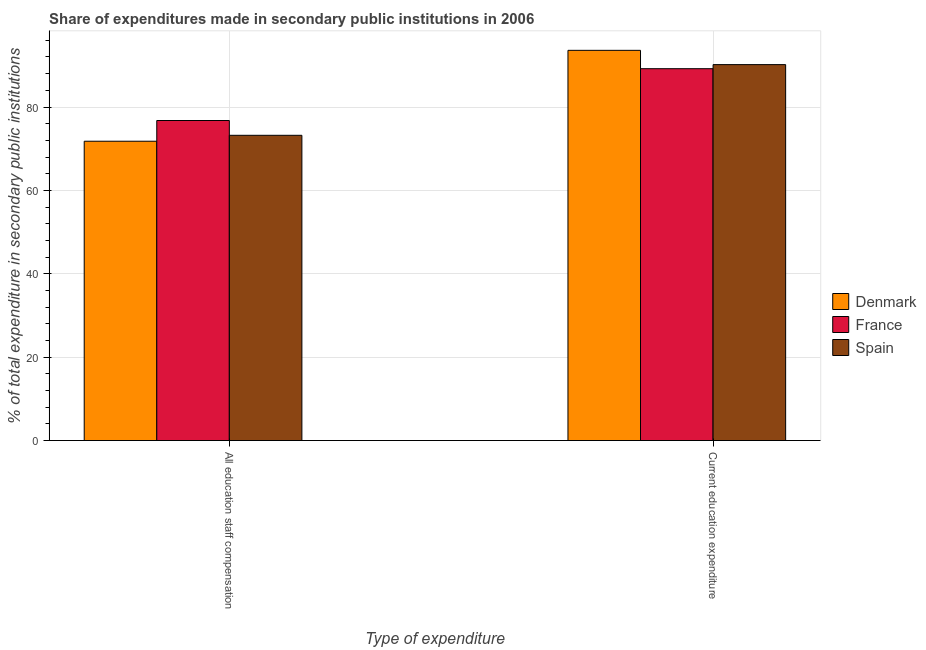How many bars are there on the 1st tick from the left?
Keep it short and to the point. 3. How many bars are there on the 1st tick from the right?
Provide a short and direct response. 3. What is the label of the 2nd group of bars from the left?
Ensure brevity in your answer.  Current education expenditure. What is the expenditure in staff compensation in Spain?
Provide a succinct answer. 73.21. Across all countries, what is the maximum expenditure in staff compensation?
Your answer should be compact. 76.76. Across all countries, what is the minimum expenditure in education?
Your answer should be very brief. 89.19. In which country was the expenditure in education maximum?
Provide a succinct answer. Denmark. In which country was the expenditure in education minimum?
Keep it short and to the point. France. What is the total expenditure in staff compensation in the graph?
Offer a terse response. 221.77. What is the difference between the expenditure in education in France and that in Spain?
Keep it short and to the point. -0.98. What is the difference between the expenditure in education in Spain and the expenditure in staff compensation in Denmark?
Offer a very short reply. 18.37. What is the average expenditure in education per country?
Make the answer very short. 90.98. What is the difference between the expenditure in staff compensation and expenditure in education in Denmark?
Keep it short and to the point. -21.8. In how many countries, is the expenditure in education greater than 76 %?
Keep it short and to the point. 3. What is the ratio of the expenditure in staff compensation in Denmark to that in France?
Provide a short and direct response. 0.94. Is the expenditure in education in Denmark less than that in France?
Your answer should be very brief. No. In how many countries, is the expenditure in education greater than the average expenditure in education taken over all countries?
Give a very brief answer. 1. What does the 1st bar from the right in All education staff compensation represents?
Keep it short and to the point. Spain. What is the difference between two consecutive major ticks on the Y-axis?
Keep it short and to the point. 20. Are the values on the major ticks of Y-axis written in scientific E-notation?
Offer a terse response. No. Does the graph contain any zero values?
Ensure brevity in your answer.  No. Does the graph contain grids?
Provide a short and direct response. Yes. Where does the legend appear in the graph?
Your answer should be very brief. Center right. How are the legend labels stacked?
Provide a short and direct response. Vertical. What is the title of the graph?
Your answer should be very brief. Share of expenditures made in secondary public institutions in 2006. What is the label or title of the X-axis?
Make the answer very short. Type of expenditure. What is the label or title of the Y-axis?
Give a very brief answer. % of total expenditure in secondary public institutions. What is the % of total expenditure in secondary public institutions in Denmark in All education staff compensation?
Your answer should be compact. 71.79. What is the % of total expenditure in secondary public institutions in France in All education staff compensation?
Keep it short and to the point. 76.76. What is the % of total expenditure in secondary public institutions of Spain in All education staff compensation?
Provide a succinct answer. 73.21. What is the % of total expenditure in secondary public institutions of Denmark in Current education expenditure?
Your answer should be compact. 93.59. What is the % of total expenditure in secondary public institutions in France in Current education expenditure?
Your response must be concise. 89.19. What is the % of total expenditure in secondary public institutions of Spain in Current education expenditure?
Keep it short and to the point. 90.17. Across all Type of expenditure, what is the maximum % of total expenditure in secondary public institutions of Denmark?
Make the answer very short. 93.59. Across all Type of expenditure, what is the maximum % of total expenditure in secondary public institutions in France?
Keep it short and to the point. 89.19. Across all Type of expenditure, what is the maximum % of total expenditure in secondary public institutions in Spain?
Ensure brevity in your answer.  90.17. Across all Type of expenditure, what is the minimum % of total expenditure in secondary public institutions of Denmark?
Provide a succinct answer. 71.79. Across all Type of expenditure, what is the minimum % of total expenditure in secondary public institutions in France?
Your answer should be compact. 76.76. Across all Type of expenditure, what is the minimum % of total expenditure in secondary public institutions of Spain?
Your answer should be very brief. 73.21. What is the total % of total expenditure in secondary public institutions of Denmark in the graph?
Provide a succinct answer. 165.39. What is the total % of total expenditure in secondary public institutions in France in the graph?
Make the answer very short. 165.95. What is the total % of total expenditure in secondary public institutions in Spain in the graph?
Offer a very short reply. 163.38. What is the difference between the % of total expenditure in secondary public institutions in Denmark in All education staff compensation and that in Current education expenditure?
Offer a terse response. -21.8. What is the difference between the % of total expenditure in secondary public institutions in France in All education staff compensation and that in Current education expenditure?
Offer a very short reply. -12.43. What is the difference between the % of total expenditure in secondary public institutions in Spain in All education staff compensation and that in Current education expenditure?
Provide a short and direct response. -16.95. What is the difference between the % of total expenditure in secondary public institutions of Denmark in All education staff compensation and the % of total expenditure in secondary public institutions of France in Current education expenditure?
Provide a succinct answer. -17.4. What is the difference between the % of total expenditure in secondary public institutions of Denmark in All education staff compensation and the % of total expenditure in secondary public institutions of Spain in Current education expenditure?
Give a very brief answer. -18.37. What is the difference between the % of total expenditure in secondary public institutions of France in All education staff compensation and the % of total expenditure in secondary public institutions of Spain in Current education expenditure?
Your response must be concise. -13.4. What is the average % of total expenditure in secondary public institutions of Denmark per Type of expenditure?
Offer a very short reply. 82.69. What is the average % of total expenditure in secondary public institutions of France per Type of expenditure?
Offer a terse response. 82.98. What is the average % of total expenditure in secondary public institutions in Spain per Type of expenditure?
Give a very brief answer. 81.69. What is the difference between the % of total expenditure in secondary public institutions of Denmark and % of total expenditure in secondary public institutions of France in All education staff compensation?
Offer a very short reply. -4.97. What is the difference between the % of total expenditure in secondary public institutions in Denmark and % of total expenditure in secondary public institutions in Spain in All education staff compensation?
Provide a succinct answer. -1.42. What is the difference between the % of total expenditure in secondary public institutions in France and % of total expenditure in secondary public institutions in Spain in All education staff compensation?
Give a very brief answer. 3.55. What is the difference between the % of total expenditure in secondary public institutions of Denmark and % of total expenditure in secondary public institutions of France in Current education expenditure?
Your answer should be very brief. 4.4. What is the difference between the % of total expenditure in secondary public institutions in Denmark and % of total expenditure in secondary public institutions in Spain in Current education expenditure?
Keep it short and to the point. 3.43. What is the difference between the % of total expenditure in secondary public institutions in France and % of total expenditure in secondary public institutions in Spain in Current education expenditure?
Provide a short and direct response. -0.98. What is the ratio of the % of total expenditure in secondary public institutions of Denmark in All education staff compensation to that in Current education expenditure?
Make the answer very short. 0.77. What is the ratio of the % of total expenditure in secondary public institutions in France in All education staff compensation to that in Current education expenditure?
Ensure brevity in your answer.  0.86. What is the ratio of the % of total expenditure in secondary public institutions in Spain in All education staff compensation to that in Current education expenditure?
Ensure brevity in your answer.  0.81. What is the difference between the highest and the second highest % of total expenditure in secondary public institutions in Denmark?
Provide a succinct answer. 21.8. What is the difference between the highest and the second highest % of total expenditure in secondary public institutions in France?
Ensure brevity in your answer.  12.43. What is the difference between the highest and the second highest % of total expenditure in secondary public institutions in Spain?
Your answer should be very brief. 16.95. What is the difference between the highest and the lowest % of total expenditure in secondary public institutions in Denmark?
Your answer should be compact. 21.8. What is the difference between the highest and the lowest % of total expenditure in secondary public institutions of France?
Keep it short and to the point. 12.43. What is the difference between the highest and the lowest % of total expenditure in secondary public institutions of Spain?
Offer a very short reply. 16.95. 